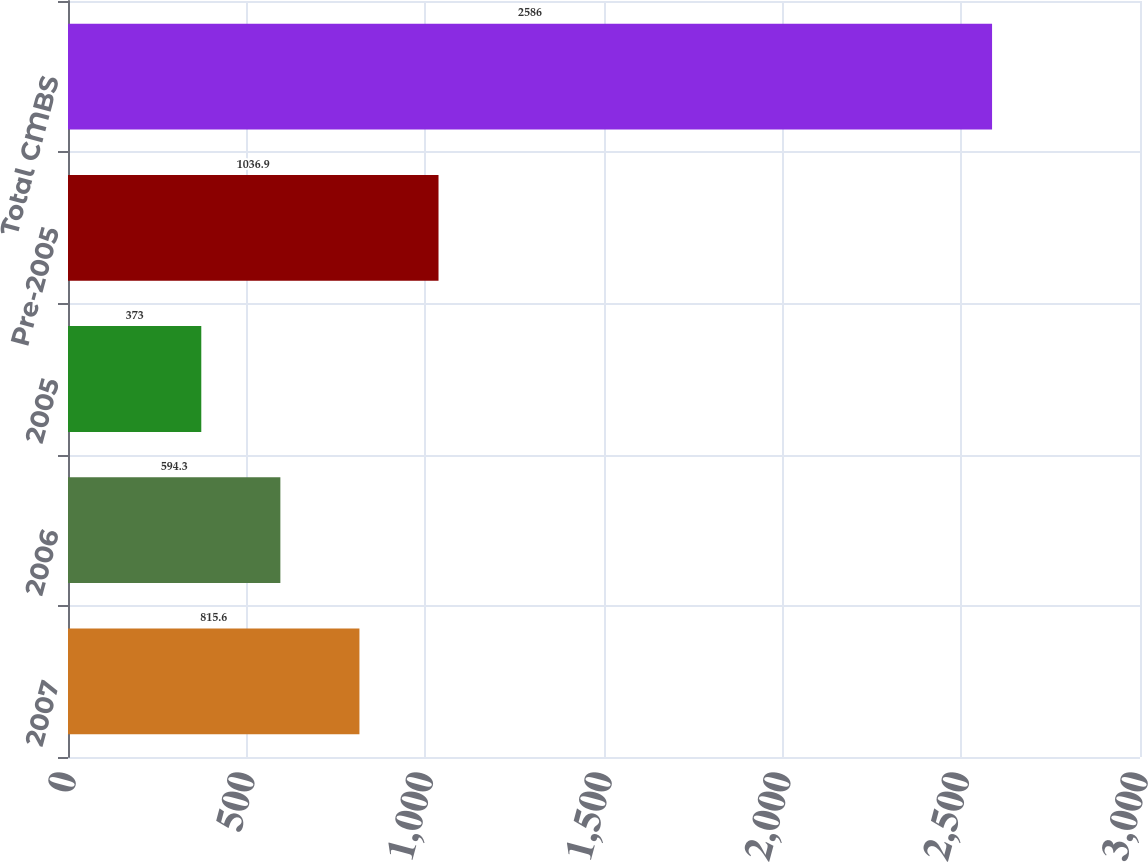Convert chart to OTSL. <chart><loc_0><loc_0><loc_500><loc_500><bar_chart><fcel>2007<fcel>2006<fcel>2005<fcel>Pre-2005<fcel>Total CMBS<nl><fcel>815.6<fcel>594.3<fcel>373<fcel>1036.9<fcel>2586<nl></chart> 